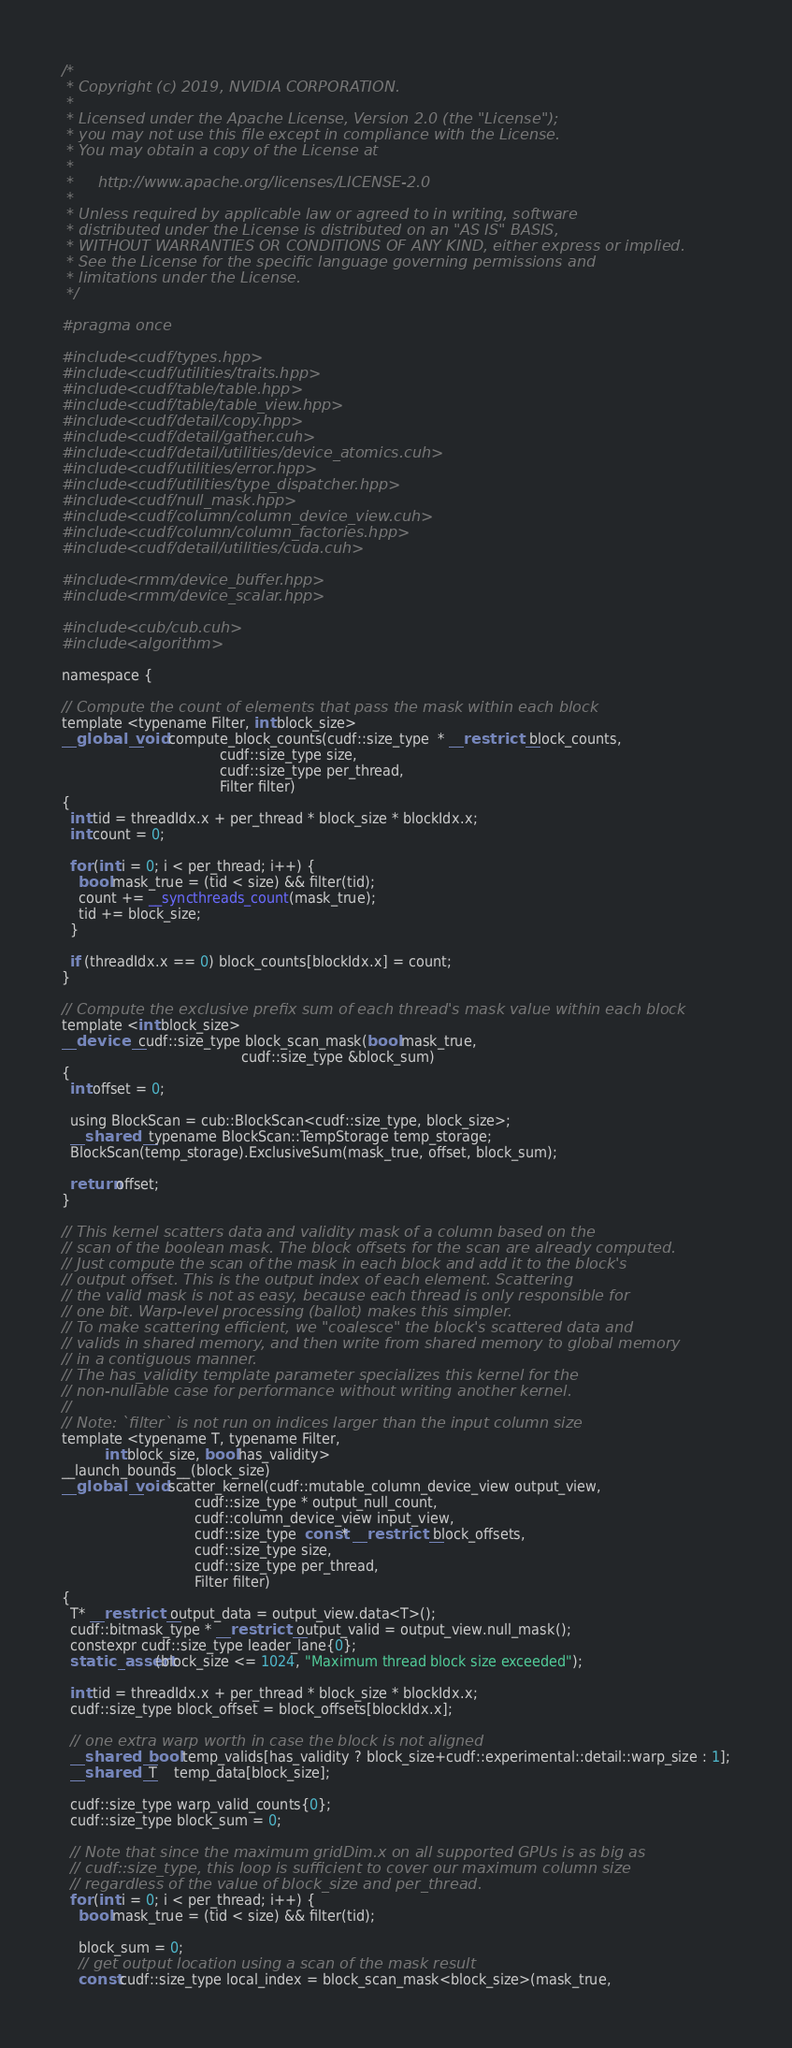<code> <loc_0><loc_0><loc_500><loc_500><_Cuda_>/*
 * Copyright (c) 2019, NVIDIA CORPORATION.
 *
 * Licensed under the Apache License, Version 2.0 (the "License");
 * you may not use this file except in compliance with the License.
 * You may obtain a copy of the License at
 *
 *     http://www.apache.org/licenses/LICENSE-2.0
 *
 * Unless required by applicable law or agreed to in writing, software
 * distributed under the License is distributed on an "AS IS" BASIS,
 * WITHOUT WARRANTIES OR CONDITIONS OF ANY KIND, either express or implied.
 * See the License for the specific language governing permissions and
 * limitations under the License.
 */

#pragma once

#include <cudf/types.hpp>
#include <cudf/utilities/traits.hpp>
#include <cudf/table/table.hpp>
#include <cudf/table/table_view.hpp>
#include <cudf/detail/copy.hpp>
#include <cudf/detail/gather.cuh>
#include <cudf/detail/utilities/device_atomics.cuh>
#include <cudf/utilities/error.hpp>
#include <cudf/utilities/type_dispatcher.hpp>
#include <cudf/null_mask.hpp>
#include <cudf/column/column_device_view.cuh>
#include <cudf/column/column_factories.hpp>
#include <cudf/detail/utilities/cuda.cuh>

#include <rmm/device_buffer.hpp>
#include <rmm/device_scalar.hpp>

#include <cub/cub.cuh>
#include <algorithm>

namespace {

// Compute the count of elements that pass the mask within each block
template <typename Filter, int block_size>
__global__ void compute_block_counts(cudf::size_type  * __restrict__ block_counts,
                                     cudf::size_type size,
                                     cudf::size_type per_thread,
                                     Filter filter)
{
  int tid = threadIdx.x + per_thread * block_size * blockIdx.x;
  int count = 0;

  for (int i = 0; i < per_thread; i++) {
    bool mask_true = (tid < size) && filter(tid);
    count += __syncthreads_count(mask_true);
    tid += block_size;
  }

  if (threadIdx.x == 0) block_counts[blockIdx.x] = count;
}

// Compute the exclusive prefix sum of each thread's mask value within each block
template <int block_size>
__device__ cudf::size_type block_scan_mask(bool mask_true,
                                          cudf::size_type &block_sum)
{
  int offset = 0;

  using BlockScan = cub::BlockScan<cudf::size_type, block_size>;
  __shared__ typename BlockScan::TempStorage temp_storage;
  BlockScan(temp_storage).ExclusiveSum(mask_true, offset, block_sum);

  return offset;
}

// This kernel scatters data and validity mask of a column based on the
// scan of the boolean mask. The block offsets for the scan are already computed.
// Just compute the scan of the mask in each block and add it to the block's
// output offset. This is the output index of each element. Scattering
// the valid mask is not as easy, because each thread is only responsible for
// one bit. Warp-level processing (ballot) makes this simpler.
// To make scattering efficient, we "coalesce" the block's scattered data and
// valids in shared memory, and then write from shared memory to global memory
// in a contiguous manner.
// The has_validity template parameter specializes this kernel for the
// non-nullable case for performance without writing another kernel.
//
// Note: `filter` is not run on indices larger than the input column size
template <typename T, typename Filter,
          int block_size, bool has_validity>
__launch_bounds__(block_size)
__global__ void scatter_kernel(cudf::mutable_column_device_view output_view,
                               cudf::size_type * output_null_count,
                               cudf::column_device_view input_view,
                               cudf::size_type  const* __restrict__ block_offsets,
                               cudf::size_type size,
                               cudf::size_type per_thread,
                               Filter filter)
{
  T* __restrict__ output_data = output_view.data<T>();
  cudf::bitmask_type * __restrict__ output_valid = output_view.null_mask();
  constexpr cudf::size_type leader_lane{0};
  static_assert(block_size <= 1024, "Maximum thread block size exceeded");

  int tid = threadIdx.x + per_thread * block_size * blockIdx.x;
  cudf::size_type block_offset = block_offsets[blockIdx.x];

  // one extra warp worth in case the block is not aligned
  __shared__ bool temp_valids[has_validity ? block_size+cudf::experimental::detail::warp_size : 1];
  __shared__ T    temp_data[block_size];

  cudf::size_type warp_valid_counts{0};
  cudf::size_type block_sum = 0;

  // Note that since the maximum gridDim.x on all supported GPUs is as big as
  // cudf::size_type, this loop is sufficient to cover our maximum column size
  // regardless of the value of block_size and per_thread.
  for (int i = 0; i < per_thread; i++) {
    bool mask_true = (tid < size) && filter(tid);

    block_sum = 0;
    // get output location using a scan of the mask result
    const cudf::size_type local_index = block_scan_mask<block_size>(mask_true,</code> 